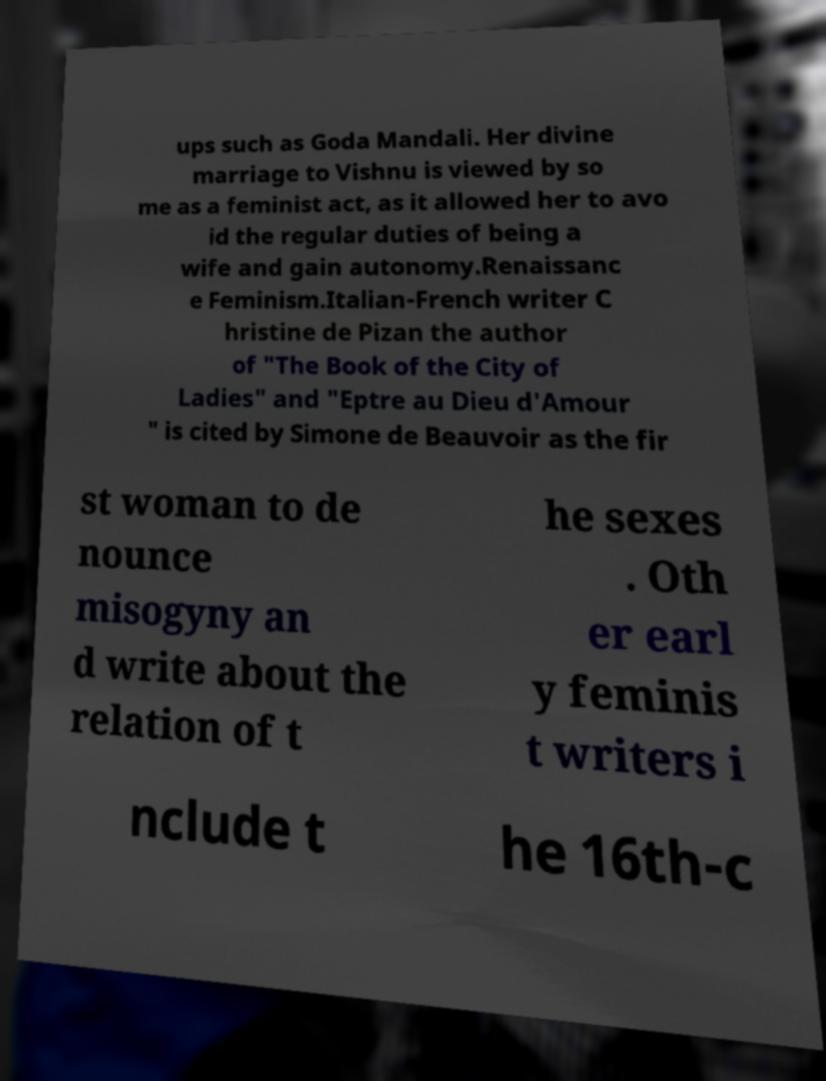I need the written content from this picture converted into text. Can you do that? ups such as Goda Mandali. Her divine marriage to Vishnu is viewed by so me as a feminist act, as it allowed her to avo id the regular duties of being a wife and gain autonomy.Renaissanc e Feminism.Italian-French writer C hristine de Pizan the author of "The Book of the City of Ladies" and "Eptre au Dieu d'Amour " is cited by Simone de Beauvoir as the fir st woman to de nounce misogyny an d write about the relation of t he sexes . Oth er earl y feminis t writers i nclude t he 16th-c 